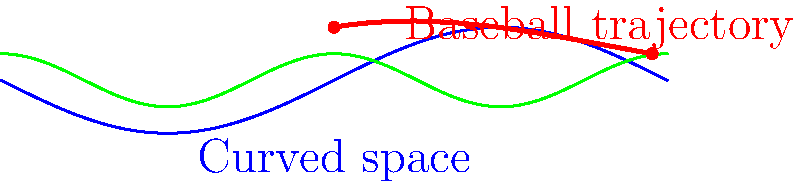In a non-Euclidean space represented by the blue curve, a baseball is thrown following the red trajectory. If the initial velocity vector is tangent to the curved space at the starting point, how does the curvature of space affect the ball's path compared to its trajectory in flat space? To understand how the curvature of space affects the baseball's trajectory, let's follow these steps:

1. In flat (Euclidean) space, a baseball thrown with no spin and only affected by gravity would follow a parabolic path.

2. In curved (non-Euclidean) space, the trajectory is influenced by the space's geometry:

   a) The ball tries to follow a geodesic, which is the shortest path between two points in curved space.
   
   b) The geodesic in curved space is analogous to a straight line in flat space.

3. The blue curve represents the curvature of space. The ball's path (red curve) deviates from what would be expected in flat space due to this curvature.

4. At the starting point, the velocity vector is tangent to the curved space. This initial condition ensures that the ball starts its journey "parallel" to the curved space.

5. As the ball travels, it continues to follow the curvature of space, resulting in a path that appears curved when projected onto a flat plane.

6. The degree of curvature in the ball's path is directly related to the curvature of the space. A more pronounced space curvature would result in a more dramatically curved ball trajectory.

7. In this specific case, the ball's path shows less downward curve than would be expected in flat space under the influence of gravity alone. This suggests that the space curvature is partially counteracting the effect of gravity.

8. The end result is a trajectory that appears to "bend" upwards relative to what would be expected in flat space, demonstrating how the geometry of space can significantly alter the path of moving objects.
Answer: The space curvature causes the baseball's trajectory to bend upwards relative to its expected path in flat space, following the geodesic of the curved space. 